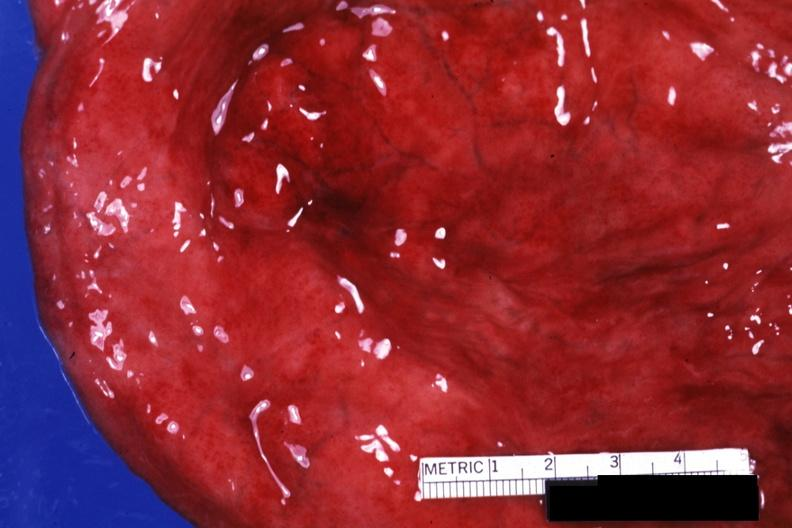s normal immature infant present?
Answer the question using a single word or phrase. No 